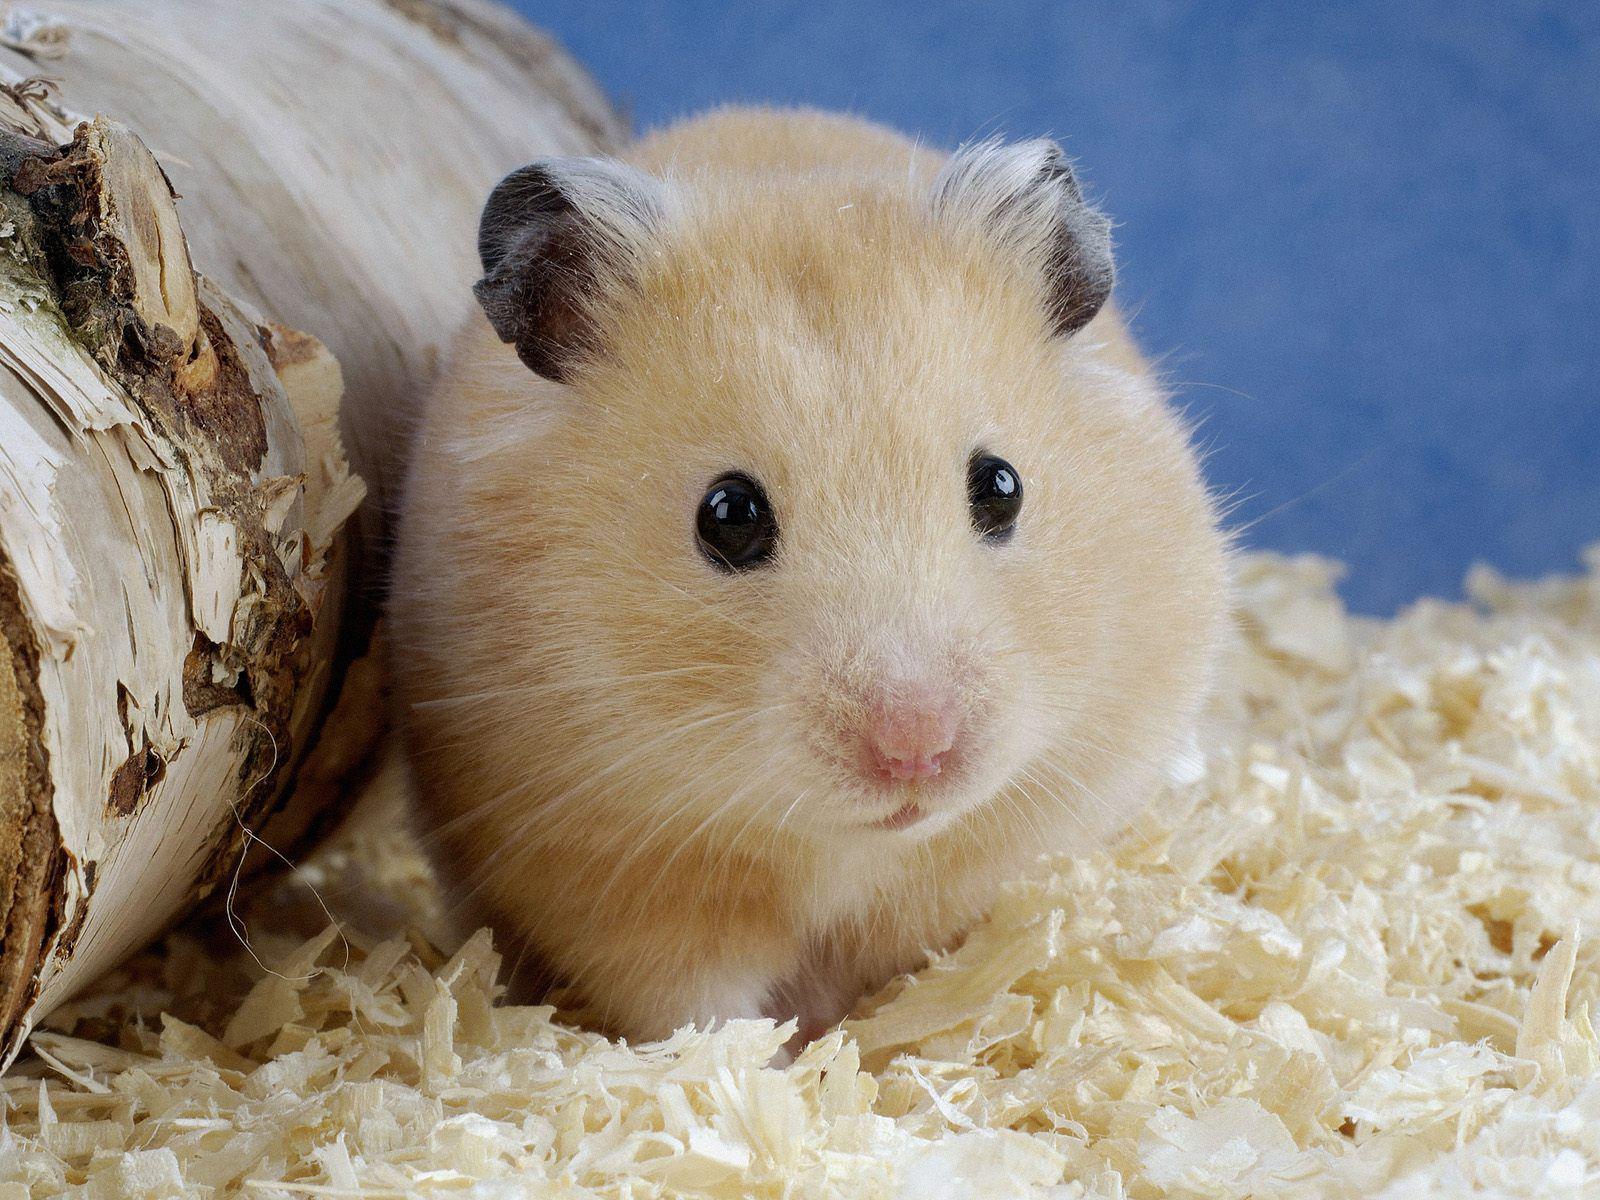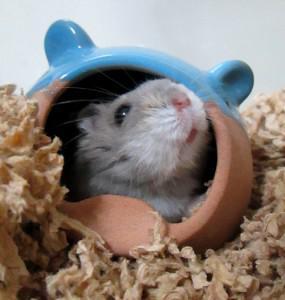The first image is the image on the left, the second image is the image on the right. For the images displayed, is the sentence "There are two mice." factually correct? Answer yes or no. Yes. The first image is the image on the left, the second image is the image on the right. Assess this claim about the two images: "There are exactly two hamsters". Correct or not? Answer yes or no. Yes. 